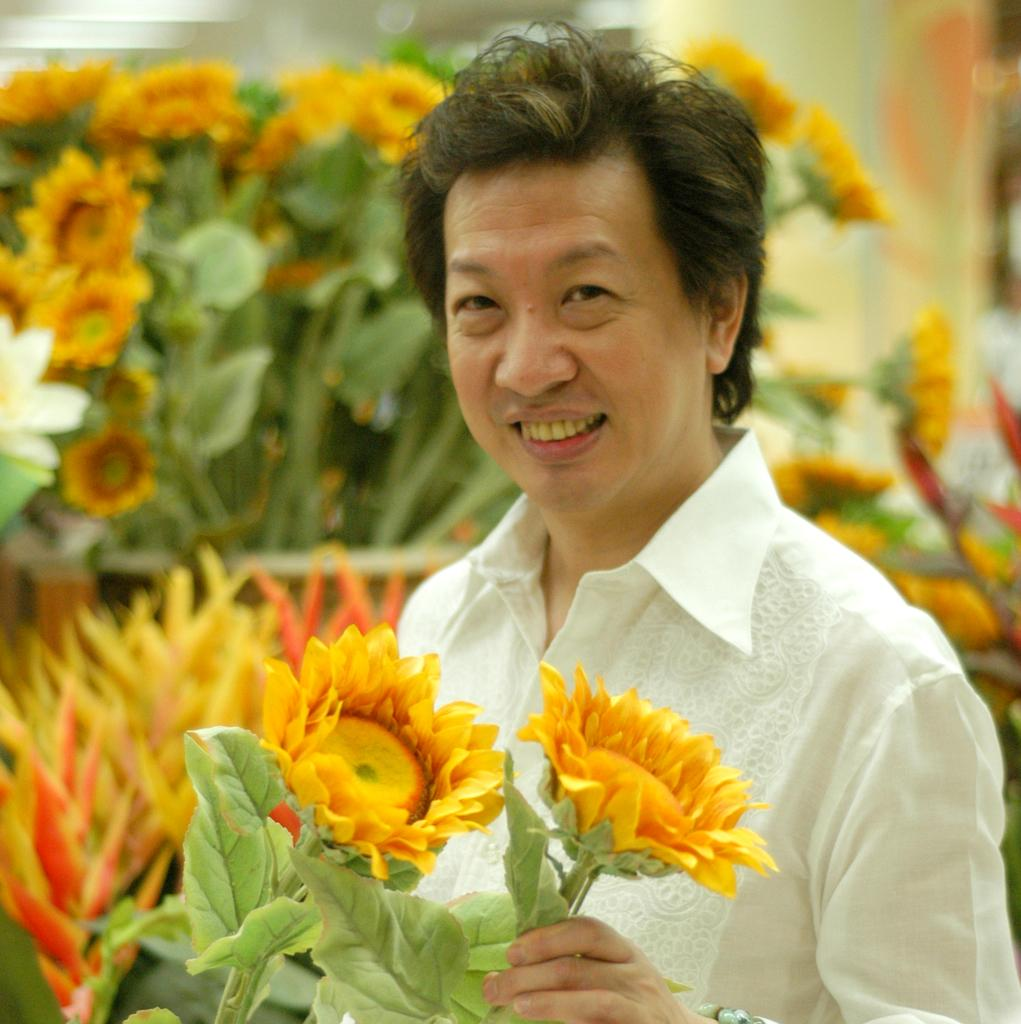Who is present in the image? There is a man in the image. What is the man wearing? The man is wearing a white shirt. What expression does the man have? The man is smiling. What is the man holding in the image? The man is holding yellow flowers with leaves. What can be seen behind the man in the image? There are many yellow flowers with leaves behind the man. What type of thought can be seen in the picture? There is no thought visible in the image, as thoughts are not something that can be seen. 